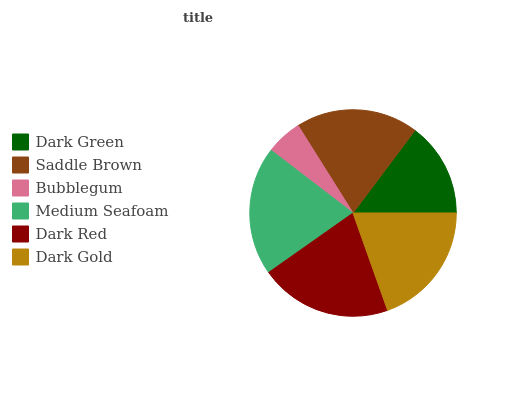Is Bubblegum the minimum?
Answer yes or no. Yes. Is Dark Red the maximum?
Answer yes or no. Yes. Is Saddle Brown the minimum?
Answer yes or no. No. Is Saddle Brown the maximum?
Answer yes or no. No. Is Saddle Brown greater than Dark Green?
Answer yes or no. Yes. Is Dark Green less than Saddle Brown?
Answer yes or no. Yes. Is Dark Green greater than Saddle Brown?
Answer yes or no. No. Is Saddle Brown less than Dark Green?
Answer yes or no. No. Is Dark Gold the high median?
Answer yes or no. Yes. Is Saddle Brown the low median?
Answer yes or no. Yes. Is Dark Green the high median?
Answer yes or no. No. Is Dark Red the low median?
Answer yes or no. No. 